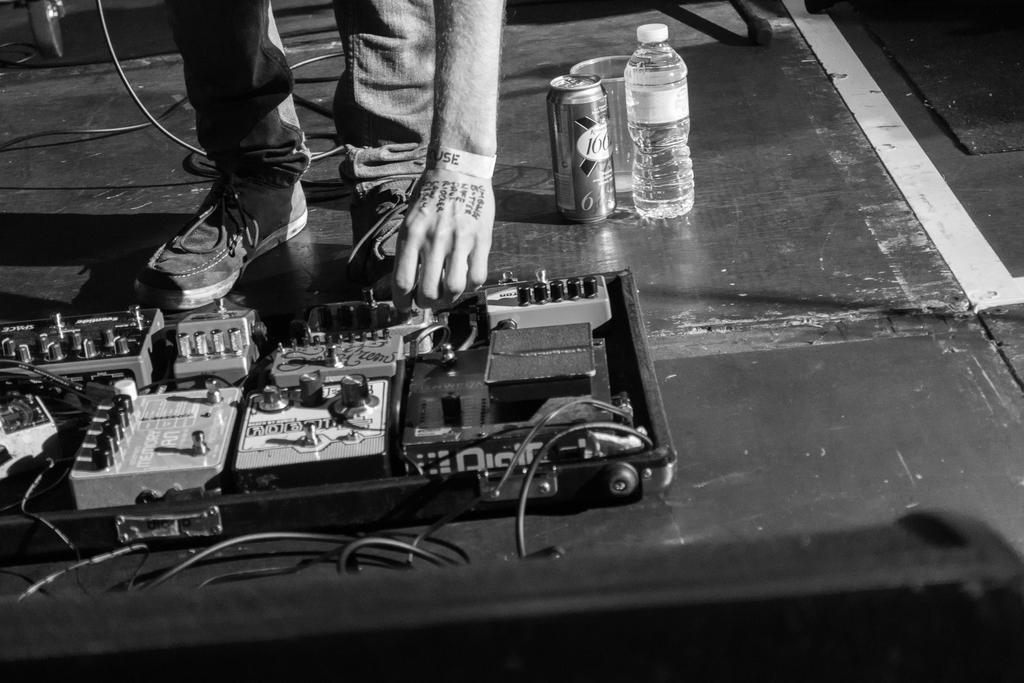How would you summarize this image in a sentence or two? This is a black and picture, in this image we can see legs and the hand of a person, and also we can see bottle, tin and some electrical objects on the surface. 